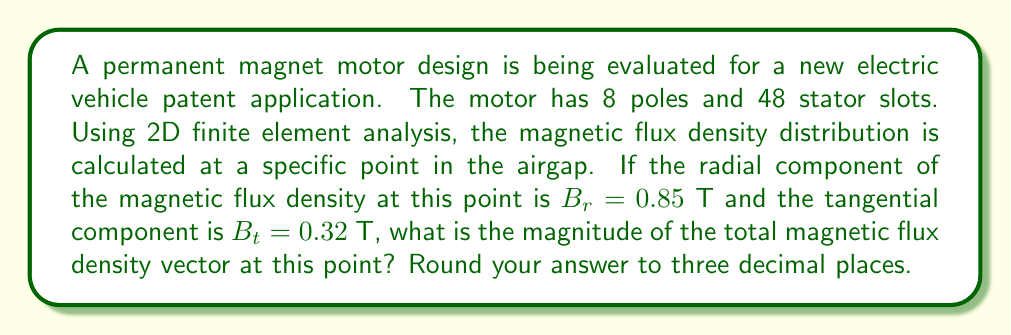Provide a solution to this math problem. To solve this problem, we need to follow these steps:

1. Understand the given information:
   - Radial component of magnetic flux density: $B_r = 0.85$ T
   - Tangential component of magnetic flux density: $B_t = 0.32$ T

2. Recall that the total magnetic flux density vector $\mathbf{B}$ is composed of the radial and tangential components:
   $$\mathbf{B} = B_r \hat{r} + B_t \hat{t}$$

3. The magnitude of the total magnetic flux density vector can be calculated using the Pythagorean theorem:
   $$|\mathbf{B}| = \sqrt{B_r^2 + B_t^2}$$

4. Substitute the given values into the equation:
   $$|\mathbf{B}| = \sqrt{(0.85\text{ T})^2 + (0.32\text{ T})^2}$$

5. Calculate the result:
   $$|\mathbf{B}| = \sqrt{0.7225\text{ T}^2 + 0.1024\text{ T}^2}$$
   $$|\mathbf{B}| = \sqrt{0.8249\text{ T}^2}$$
   $$|\mathbf{B}| = 0.90823\text{ T}$$

6. Round the result to three decimal places:
   $$|\mathbf{B}| \approx 0.908\text{ T}$$

This calculation provides the magnitude of the total magnetic flux density vector at the specified point in the airgap, which is an important parameter for evaluating the performance and efficiency of the permanent magnet motor design.
Answer: 0.908 T 